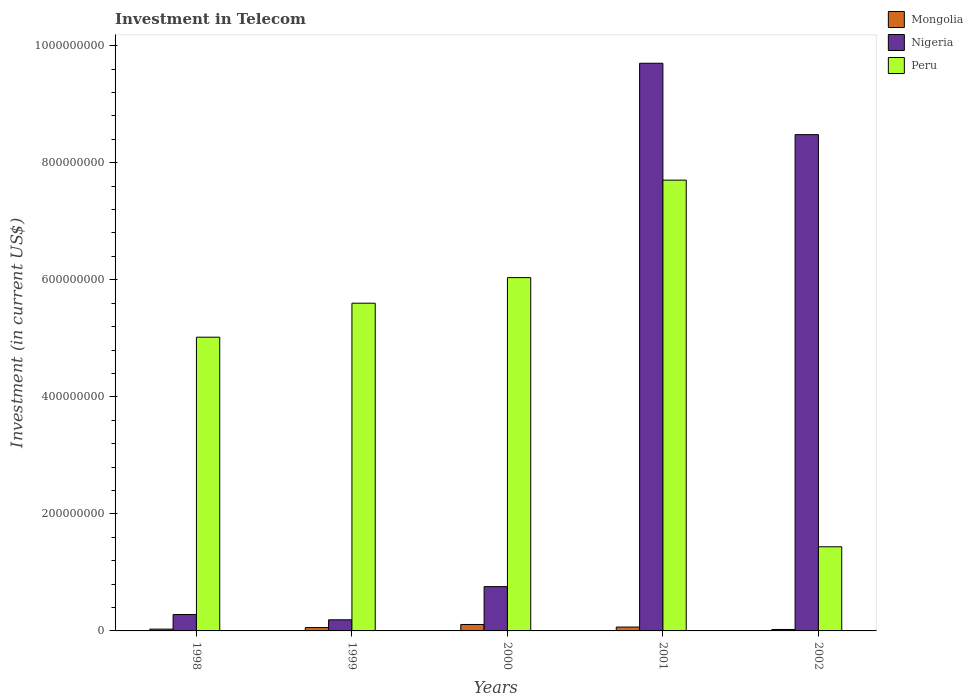Are the number of bars per tick equal to the number of legend labels?
Give a very brief answer. Yes. Are the number of bars on each tick of the X-axis equal?
Offer a terse response. Yes. How many bars are there on the 4th tick from the left?
Provide a succinct answer. 3. What is the amount invested in telecom in Peru in 2000?
Your answer should be very brief. 6.04e+08. Across all years, what is the maximum amount invested in telecom in Peru?
Make the answer very short. 7.70e+08. Across all years, what is the minimum amount invested in telecom in Peru?
Give a very brief answer. 1.44e+08. What is the total amount invested in telecom in Nigeria in the graph?
Ensure brevity in your answer.  1.94e+09. What is the difference between the amount invested in telecom in Peru in 2000 and that in 2002?
Your response must be concise. 4.60e+08. What is the difference between the amount invested in telecom in Peru in 2000 and the amount invested in telecom in Nigeria in 1999?
Keep it short and to the point. 5.85e+08. What is the average amount invested in telecom in Mongolia per year?
Offer a very short reply. 5.77e+06. In the year 1999, what is the difference between the amount invested in telecom in Mongolia and amount invested in telecom in Peru?
Offer a very short reply. -5.54e+08. What is the ratio of the amount invested in telecom in Peru in 1999 to that in 2001?
Make the answer very short. 0.73. Is the difference between the amount invested in telecom in Mongolia in 2000 and 2002 greater than the difference between the amount invested in telecom in Peru in 2000 and 2002?
Keep it short and to the point. No. What is the difference between the highest and the second highest amount invested in telecom in Nigeria?
Give a very brief answer. 1.22e+08. What is the difference between the highest and the lowest amount invested in telecom in Peru?
Offer a terse response. 6.26e+08. Is the sum of the amount invested in telecom in Peru in 1999 and 2001 greater than the maximum amount invested in telecom in Nigeria across all years?
Your response must be concise. Yes. What does the 3rd bar from the left in 2000 represents?
Offer a very short reply. Peru. What does the 1st bar from the right in 2002 represents?
Your answer should be very brief. Peru. Is it the case that in every year, the sum of the amount invested in telecom in Peru and amount invested in telecom in Mongolia is greater than the amount invested in telecom in Nigeria?
Provide a short and direct response. No. Are all the bars in the graph horizontal?
Your response must be concise. No. Are the values on the major ticks of Y-axis written in scientific E-notation?
Make the answer very short. No. Does the graph contain grids?
Your answer should be very brief. No. What is the title of the graph?
Keep it short and to the point. Investment in Telecom. What is the label or title of the X-axis?
Give a very brief answer. Years. What is the label or title of the Y-axis?
Give a very brief answer. Investment (in current US$). What is the Investment (in current US$) of Mongolia in 1998?
Your answer should be compact. 3.06e+06. What is the Investment (in current US$) in Nigeria in 1998?
Give a very brief answer. 2.80e+07. What is the Investment (in current US$) of Peru in 1998?
Offer a very short reply. 5.02e+08. What is the Investment (in current US$) of Mongolia in 1999?
Make the answer very short. 5.70e+06. What is the Investment (in current US$) in Nigeria in 1999?
Provide a succinct answer. 1.90e+07. What is the Investment (in current US$) in Peru in 1999?
Keep it short and to the point. 5.60e+08. What is the Investment (in current US$) in Mongolia in 2000?
Your response must be concise. 1.10e+07. What is the Investment (in current US$) in Nigeria in 2000?
Your response must be concise. 7.57e+07. What is the Investment (in current US$) in Peru in 2000?
Provide a short and direct response. 6.04e+08. What is the Investment (in current US$) of Mongolia in 2001?
Provide a short and direct response. 6.60e+06. What is the Investment (in current US$) in Nigeria in 2001?
Make the answer very short. 9.70e+08. What is the Investment (in current US$) of Peru in 2001?
Give a very brief answer. 7.70e+08. What is the Investment (in current US$) in Mongolia in 2002?
Give a very brief answer. 2.50e+06. What is the Investment (in current US$) of Nigeria in 2002?
Offer a terse response. 8.48e+08. What is the Investment (in current US$) in Peru in 2002?
Provide a succinct answer. 1.44e+08. Across all years, what is the maximum Investment (in current US$) in Mongolia?
Provide a succinct answer. 1.10e+07. Across all years, what is the maximum Investment (in current US$) in Nigeria?
Give a very brief answer. 9.70e+08. Across all years, what is the maximum Investment (in current US$) of Peru?
Your response must be concise. 7.70e+08. Across all years, what is the minimum Investment (in current US$) of Mongolia?
Give a very brief answer. 2.50e+06. Across all years, what is the minimum Investment (in current US$) of Nigeria?
Offer a terse response. 1.90e+07. Across all years, what is the minimum Investment (in current US$) in Peru?
Offer a terse response. 1.44e+08. What is the total Investment (in current US$) in Mongolia in the graph?
Provide a succinct answer. 2.89e+07. What is the total Investment (in current US$) in Nigeria in the graph?
Your answer should be very brief. 1.94e+09. What is the total Investment (in current US$) in Peru in the graph?
Your response must be concise. 2.58e+09. What is the difference between the Investment (in current US$) in Mongolia in 1998 and that in 1999?
Ensure brevity in your answer.  -2.64e+06. What is the difference between the Investment (in current US$) of Nigeria in 1998 and that in 1999?
Offer a very short reply. 9.00e+06. What is the difference between the Investment (in current US$) in Peru in 1998 and that in 1999?
Your answer should be compact. -5.81e+07. What is the difference between the Investment (in current US$) of Mongolia in 1998 and that in 2000?
Offer a very short reply. -7.94e+06. What is the difference between the Investment (in current US$) in Nigeria in 1998 and that in 2000?
Provide a succinct answer. -4.77e+07. What is the difference between the Investment (in current US$) of Peru in 1998 and that in 2000?
Provide a succinct answer. -1.02e+08. What is the difference between the Investment (in current US$) of Mongolia in 1998 and that in 2001?
Your response must be concise. -3.54e+06. What is the difference between the Investment (in current US$) in Nigeria in 1998 and that in 2001?
Provide a short and direct response. -9.42e+08. What is the difference between the Investment (in current US$) of Peru in 1998 and that in 2001?
Provide a succinct answer. -2.68e+08. What is the difference between the Investment (in current US$) of Mongolia in 1998 and that in 2002?
Offer a terse response. 5.60e+05. What is the difference between the Investment (in current US$) of Nigeria in 1998 and that in 2002?
Offer a terse response. -8.20e+08. What is the difference between the Investment (in current US$) in Peru in 1998 and that in 2002?
Ensure brevity in your answer.  3.58e+08. What is the difference between the Investment (in current US$) of Mongolia in 1999 and that in 2000?
Keep it short and to the point. -5.30e+06. What is the difference between the Investment (in current US$) in Nigeria in 1999 and that in 2000?
Give a very brief answer. -5.67e+07. What is the difference between the Investment (in current US$) of Peru in 1999 and that in 2000?
Your answer should be very brief. -4.37e+07. What is the difference between the Investment (in current US$) in Mongolia in 1999 and that in 2001?
Provide a short and direct response. -9.00e+05. What is the difference between the Investment (in current US$) of Nigeria in 1999 and that in 2001?
Your response must be concise. -9.51e+08. What is the difference between the Investment (in current US$) of Peru in 1999 and that in 2001?
Offer a terse response. -2.10e+08. What is the difference between the Investment (in current US$) of Mongolia in 1999 and that in 2002?
Your response must be concise. 3.20e+06. What is the difference between the Investment (in current US$) of Nigeria in 1999 and that in 2002?
Provide a short and direct response. -8.29e+08. What is the difference between the Investment (in current US$) in Peru in 1999 and that in 2002?
Keep it short and to the point. 4.16e+08. What is the difference between the Investment (in current US$) of Mongolia in 2000 and that in 2001?
Your answer should be compact. 4.40e+06. What is the difference between the Investment (in current US$) of Nigeria in 2000 and that in 2001?
Make the answer very short. -8.94e+08. What is the difference between the Investment (in current US$) of Peru in 2000 and that in 2001?
Your response must be concise. -1.67e+08. What is the difference between the Investment (in current US$) in Mongolia in 2000 and that in 2002?
Offer a terse response. 8.50e+06. What is the difference between the Investment (in current US$) of Nigeria in 2000 and that in 2002?
Ensure brevity in your answer.  -7.72e+08. What is the difference between the Investment (in current US$) in Peru in 2000 and that in 2002?
Offer a very short reply. 4.60e+08. What is the difference between the Investment (in current US$) of Mongolia in 2001 and that in 2002?
Make the answer very short. 4.10e+06. What is the difference between the Investment (in current US$) in Nigeria in 2001 and that in 2002?
Keep it short and to the point. 1.22e+08. What is the difference between the Investment (in current US$) in Peru in 2001 and that in 2002?
Keep it short and to the point. 6.26e+08. What is the difference between the Investment (in current US$) of Mongolia in 1998 and the Investment (in current US$) of Nigeria in 1999?
Your answer should be very brief. -1.59e+07. What is the difference between the Investment (in current US$) in Mongolia in 1998 and the Investment (in current US$) in Peru in 1999?
Your response must be concise. -5.57e+08. What is the difference between the Investment (in current US$) of Nigeria in 1998 and the Investment (in current US$) of Peru in 1999?
Provide a short and direct response. -5.32e+08. What is the difference between the Investment (in current US$) in Mongolia in 1998 and the Investment (in current US$) in Nigeria in 2000?
Your response must be concise. -7.26e+07. What is the difference between the Investment (in current US$) in Mongolia in 1998 and the Investment (in current US$) in Peru in 2000?
Make the answer very short. -6.01e+08. What is the difference between the Investment (in current US$) of Nigeria in 1998 and the Investment (in current US$) of Peru in 2000?
Keep it short and to the point. -5.76e+08. What is the difference between the Investment (in current US$) in Mongolia in 1998 and the Investment (in current US$) in Nigeria in 2001?
Your answer should be very brief. -9.67e+08. What is the difference between the Investment (in current US$) of Mongolia in 1998 and the Investment (in current US$) of Peru in 2001?
Your answer should be compact. -7.67e+08. What is the difference between the Investment (in current US$) of Nigeria in 1998 and the Investment (in current US$) of Peru in 2001?
Give a very brief answer. -7.42e+08. What is the difference between the Investment (in current US$) of Mongolia in 1998 and the Investment (in current US$) of Nigeria in 2002?
Your answer should be compact. -8.45e+08. What is the difference between the Investment (in current US$) of Mongolia in 1998 and the Investment (in current US$) of Peru in 2002?
Your response must be concise. -1.41e+08. What is the difference between the Investment (in current US$) in Nigeria in 1998 and the Investment (in current US$) in Peru in 2002?
Make the answer very short. -1.16e+08. What is the difference between the Investment (in current US$) in Mongolia in 1999 and the Investment (in current US$) in Nigeria in 2000?
Make the answer very short. -7.00e+07. What is the difference between the Investment (in current US$) of Mongolia in 1999 and the Investment (in current US$) of Peru in 2000?
Your response must be concise. -5.98e+08. What is the difference between the Investment (in current US$) in Nigeria in 1999 and the Investment (in current US$) in Peru in 2000?
Give a very brief answer. -5.85e+08. What is the difference between the Investment (in current US$) of Mongolia in 1999 and the Investment (in current US$) of Nigeria in 2001?
Keep it short and to the point. -9.64e+08. What is the difference between the Investment (in current US$) of Mongolia in 1999 and the Investment (in current US$) of Peru in 2001?
Your answer should be very brief. -7.65e+08. What is the difference between the Investment (in current US$) of Nigeria in 1999 and the Investment (in current US$) of Peru in 2001?
Give a very brief answer. -7.51e+08. What is the difference between the Investment (in current US$) in Mongolia in 1999 and the Investment (in current US$) in Nigeria in 2002?
Offer a terse response. -8.42e+08. What is the difference between the Investment (in current US$) of Mongolia in 1999 and the Investment (in current US$) of Peru in 2002?
Your answer should be very brief. -1.38e+08. What is the difference between the Investment (in current US$) in Nigeria in 1999 and the Investment (in current US$) in Peru in 2002?
Offer a very short reply. -1.25e+08. What is the difference between the Investment (in current US$) of Mongolia in 2000 and the Investment (in current US$) of Nigeria in 2001?
Provide a short and direct response. -9.59e+08. What is the difference between the Investment (in current US$) of Mongolia in 2000 and the Investment (in current US$) of Peru in 2001?
Your answer should be very brief. -7.59e+08. What is the difference between the Investment (in current US$) of Nigeria in 2000 and the Investment (in current US$) of Peru in 2001?
Provide a short and direct response. -6.95e+08. What is the difference between the Investment (in current US$) of Mongolia in 2000 and the Investment (in current US$) of Nigeria in 2002?
Offer a terse response. -8.37e+08. What is the difference between the Investment (in current US$) in Mongolia in 2000 and the Investment (in current US$) in Peru in 2002?
Provide a short and direct response. -1.33e+08. What is the difference between the Investment (in current US$) in Nigeria in 2000 and the Investment (in current US$) in Peru in 2002?
Keep it short and to the point. -6.81e+07. What is the difference between the Investment (in current US$) of Mongolia in 2001 and the Investment (in current US$) of Nigeria in 2002?
Provide a succinct answer. -8.41e+08. What is the difference between the Investment (in current US$) of Mongolia in 2001 and the Investment (in current US$) of Peru in 2002?
Provide a succinct answer. -1.37e+08. What is the difference between the Investment (in current US$) in Nigeria in 2001 and the Investment (in current US$) in Peru in 2002?
Ensure brevity in your answer.  8.26e+08. What is the average Investment (in current US$) in Mongolia per year?
Ensure brevity in your answer.  5.77e+06. What is the average Investment (in current US$) of Nigeria per year?
Keep it short and to the point. 3.88e+08. What is the average Investment (in current US$) of Peru per year?
Ensure brevity in your answer.  5.16e+08. In the year 1998, what is the difference between the Investment (in current US$) in Mongolia and Investment (in current US$) in Nigeria?
Offer a very short reply. -2.49e+07. In the year 1998, what is the difference between the Investment (in current US$) in Mongolia and Investment (in current US$) in Peru?
Make the answer very short. -4.99e+08. In the year 1998, what is the difference between the Investment (in current US$) of Nigeria and Investment (in current US$) of Peru?
Ensure brevity in your answer.  -4.74e+08. In the year 1999, what is the difference between the Investment (in current US$) in Mongolia and Investment (in current US$) in Nigeria?
Provide a succinct answer. -1.33e+07. In the year 1999, what is the difference between the Investment (in current US$) of Mongolia and Investment (in current US$) of Peru?
Offer a terse response. -5.54e+08. In the year 1999, what is the difference between the Investment (in current US$) in Nigeria and Investment (in current US$) in Peru?
Provide a short and direct response. -5.41e+08. In the year 2000, what is the difference between the Investment (in current US$) of Mongolia and Investment (in current US$) of Nigeria?
Offer a terse response. -6.47e+07. In the year 2000, what is the difference between the Investment (in current US$) of Mongolia and Investment (in current US$) of Peru?
Offer a terse response. -5.93e+08. In the year 2000, what is the difference between the Investment (in current US$) in Nigeria and Investment (in current US$) in Peru?
Make the answer very short. -5.28e+08. In the year 2001, what is the difference between the Investment (in current US$) of Mongolia and Investment (in current US$) of Nigeria?
Your answer should be very brief. -9.63e+08. In the year 2001, what is the difference between the Investment (in current US$) in Mongolia and Investment (in current US$) in Peru?
Offer a very short reply. -7.64e+08. In the year 2001, what is the difference between the Investment (in current US$) of Nigeria and Investment (in current US$) of Peru?
Provide a short and direct response. 2.00e+08. In the year 2002, what is the difference between the Investment (in current US$) in Mongolia and Investment (in current US$) in Nigeria?
Offer a terse response. -8.46e+08. In the year 2002, what is the difference between the Investment (in current US$) in Mongolia and Investment (in current US$) in Peru?
Provide a short and direct response. -1.41e+08. In the year 2002, what is the difference between the Investment (in current US$) in Nigeria and Investment (in current US$) in Peru?
Make the answer very short. 7.04e+08. What is the ratio of the Investment (in current US$) in Mongolia in 1998 to that in 1999?
Offer a terse response. 0.54. What is the ratio of the Investment (in current US$) in Nigeria in 1998 to that in 1999?
Your response must be concise. 1.47. What is the ratio of the Investment (in current US$) in Peru in 1998 to that in 1999?
Provide a succinct answer. 0.9. What is the ratio of the Investment (in current US$) of Mongolia in 1998 to that in 2000?
Your answer should be compact. 0.28. What is the ratio of the Investment (in current US$) in Nigeria in 1998 to that in 2000?
Make the answer very short. 0.37. What is the ratio of the Investment (in current US$) in Peru in 1998 to that in 2000?
Give a very brief answer. 0.83. What is the ratio of the Investment (in current US$) in Mongolia in 1998 to that in 2001?
Make the answer very short. 0.46. What is the ratio of the Investment (in current US$) of Nigeria in 1998 to that in 2001?
Keep it short and to the point. 0.03. What is the ratio of the Investment (in current US$) in Peru in 1998 to that in 2001?
Keep it short and to the point. 0.65. What is the ratio of the Investment (in current US$) in Mongolia in 1998 to that in 2002?
Make the answer very short. 1.22. What is the ratio of the Investment (in current US$) in Nigeria in 1998 to that in 2002?
Provide a short and direct response. 0.03. What is the ratio of the Investment (in current US$) in Peru in 1998 to that in 2002?
Your answer should be very brief. 3.49. What is the ratio of the Investment (in current US$) in Mongolia in 1999 to that in 2000?
Your response must be concise. 0.52. What is the ratio of the Investment (in current US$) in Nigeria in 1999 to that in 2000?
Offer a very short reply. 0.25. What is the ratio of the Investment (in current US$) in Peru in 1999 to that in 2000?
Give a very brief answer. 0.93. What is the ratio of the Investment (in current US$) of Mongolia in 1999 to that in 2001?
Offer a very short reply. 0.86. What is the ratio of the Investment (in current US$) in Nigeria in 1999 to that in 2001?
Offer a terse response. 0.02. What is the ratio of the Investment (in current US$) in Peru in 1999 to that in 2001?
Provide a succinct answer. 0.73. What is the ratio of the Investment (in current US$) of Mongolia in 1999 to that in 2002?
Offer a terse response. 2.28. What is the ratio of the Investment (in current US$) in Nigeria in 1999 to that in 2002?
Offer a very short reply. 0.02. What is the ratio of the Investment (in current US$) in Peru in 1999 to that in 2002?
Your answer should be very brief. 3.89. What is the ratio of the Investment (in current US$) of Nigeria in 2000 to that in 2001?
Your answer should be very brief. 0.08. What is the ratio of the Investment (in current US$) in Peru in 2000 to that in 2001?
Ensure brevity in your answer.  0.78. What is the ratio of the Investment (in current US$) in Nigeria in 2000 to that in 2002?
Ensure brevity in your answer.  0.09. What is the ratio of the Investment (in current US$) of Peru in 2000 to that in 2002?
Your answer should be very brief. 4.2. What is the ratio of the Investment (in current US$) in Mongolia in 2001 to that in 2002?
Provide a short and direct response. 2.64. What is the ratio of the Investment (in current US$) in Nigeria in 2001 to that in 2002?
Offer a terse response. 1.14. What is the ratio of the Investment (in current US$) of Peru in 2001 to that in 2002?
Provide a short and direct response. 5.36. What is the difference between the highest and the second highest Investment (in current US$) of Mongolia?
Provide a short and direct response. 4.40e+06. What is the difference between the highest and the second highest Investment (in current US$) in Nigeria?
Keep it short and to the point. 1.22e+08. What is the difference between the highest and the second highest Investment (in current US$) in Peru?
Offer a very short reply. 1.67e+08. What is the difference between the highest and the lowest Investment (in current US$) of Mongolia?
Ensure brevity in your answer.  8.50e+06. What is the difference between the highest and the lowest Investment (in current US$) in Nigeria?
Provide a succinct answer. 9.51e+08. What is the difference between the highest and the lowest Investment (in current US$) in Peru?
Make the answer very short. 6.26e+08. 